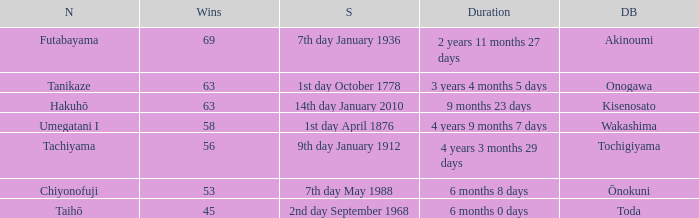How many wins were held before being defeated by toda? 1.0. Can you parse all the data within this table? {'header': ['N', 'Wins', 'S', 'Duration', 'DB'], 'rows': [['Futabayama', '69', '7th day January 1936', '2 years 11 months 27 days', 'Akinoumi'], ['Tanikaze', '63', '1st day October 1778', '3 years 4 months 5 days', 'Onogawa'], ['Hakuhō', '63', '14th day January 2010', '9 months 23 days', 'Kisenosato'], ['Umegatani I', '58', '1st day April 1876', '4 years 9 months 7 days', 'Wakashima'], ['Tachiyama', '56', '9th day January 1912', '4 years 3 months 29 days', 'Tochigiyama'], ['Chiyonofuji', '53', '7th day May 1988', '6 months 8 days', 'Ōnokuni'], ['Taihō', '45', '2nd day September 1968', '6 months 0 days', 'Toda']]} 